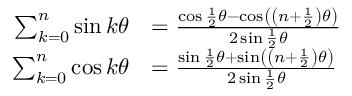<formula> <loc_0><loc_0><loc_500><loc_500>{ \begin{array} { r l } { \sum _ { k = 0 } ^ { n } \sin k \theta } & { = { \frac { \cos { \frac { 1 } { 2 } } \theta - \cos \left ( \left ( n + { \frac { 1 } { 2 } } \right ) \theta \right ) } { 2 \sin { \frac { 1 } { 2 } } \theta } } } \\ { \sum _ { k = 0 } ^ { n } \cos k \theta } & { = { \frac { \sin { \frac { 1 } { 2 } } \theta + \sin \left ( \left ( n + { \frac { 1 } { 2 } } \right ) \theta \right ) } { 2 \sin { \frac { 1 } { 2 } } \theta } } } \end{array} }</formula> 